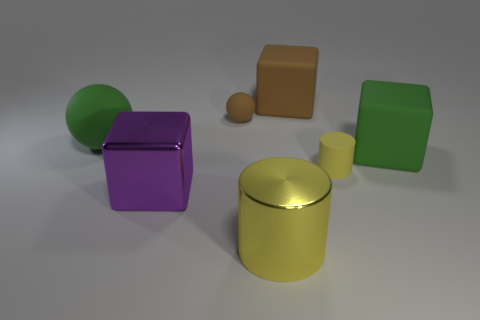Imagine these items are part of a puzzle, what could be the solving criterion? If these items were elements of a puzzle, the solving criterion might involve arranging the shapes according to specific rules based on their attributes. For instance, the puzzle could require sorting the items by color, shape, or size in ascending or descending order, or perhaps grouping them to create an aesthetically pleasing balance of form and hue. 